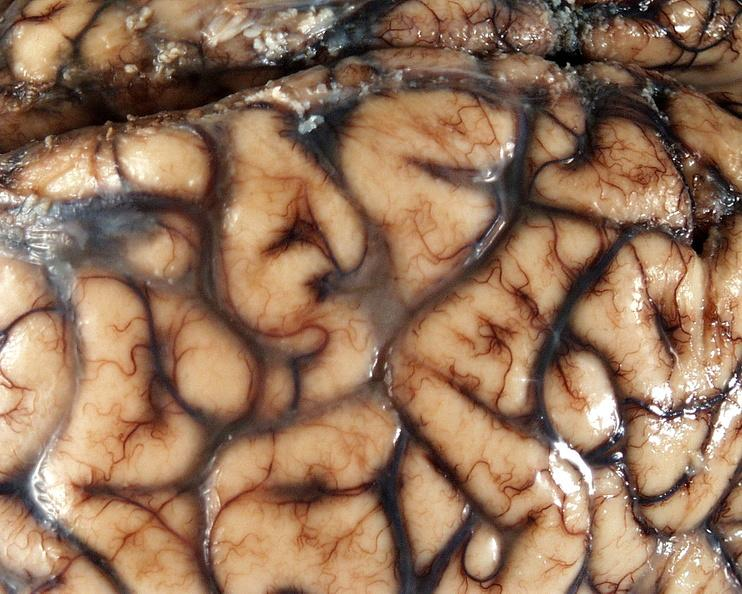what does this image show?
Answer the question using a single word or phrase. Brain 